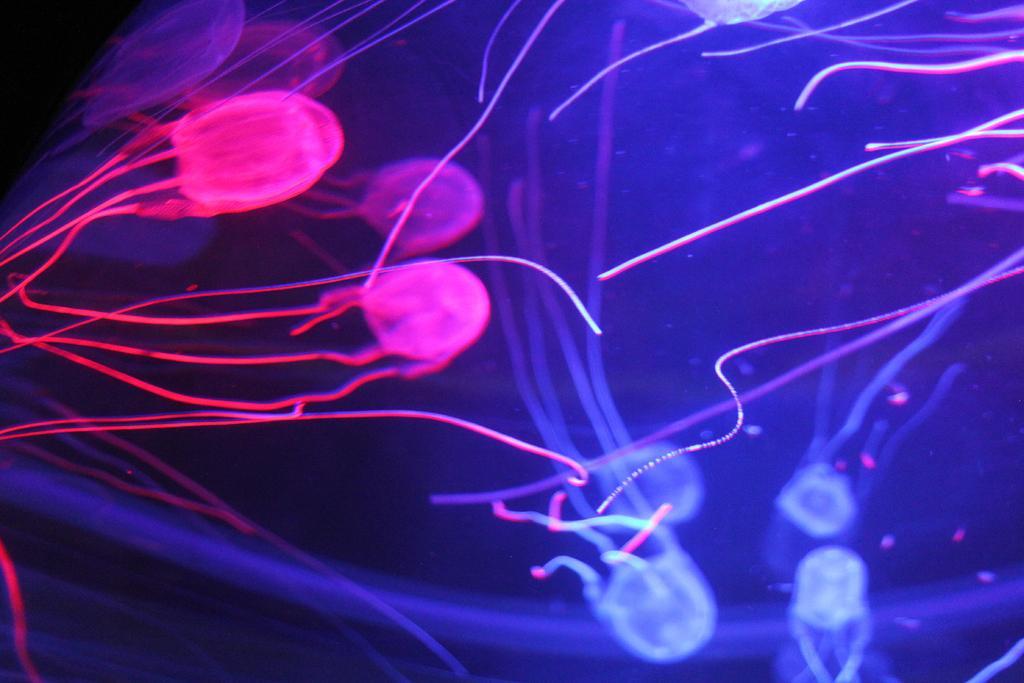Could you give a brief overview of what you see in this image? In this image we can see microorganisms. 